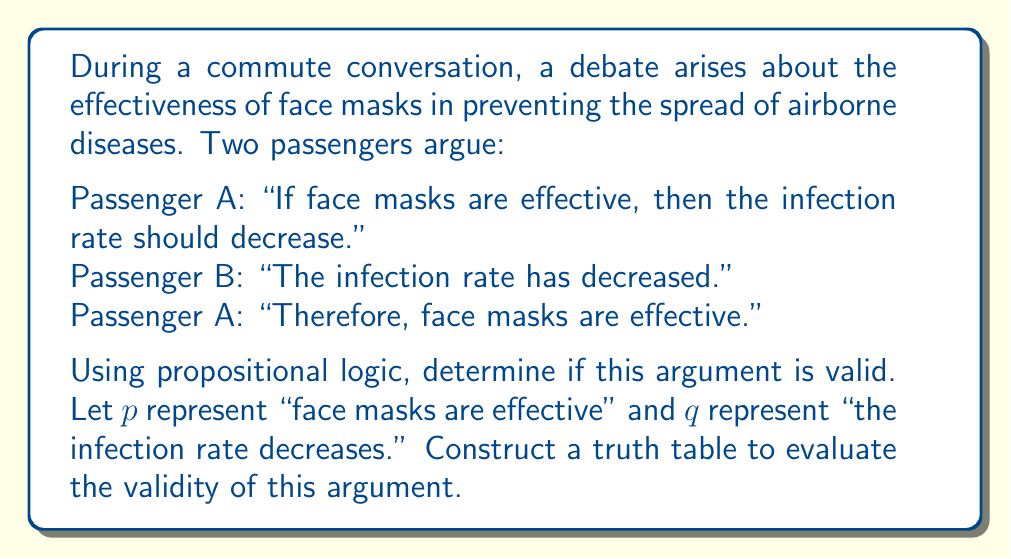Help me with this question. To evaluate the validity of this argument using propositional logic, we need to analyze the logical structure and construct a truth table. The argument can be broken down as follows:

1. Premise 1: $p \rightarrow q$ (If face masks are effective, then the infection rate should decrease)
2. Premise 2: $q$ (The infection rate has decreased)
3. Conclusion: $p$ (Therefore, face masks are effective)

This argument form is known as the fallacy of affirming the consequent. To prove its invalidity, we'll construct a truth table:

$$
\begin{array}{|c|c|c|c|c|}
\hline
p & q & p \rightarrow q & q & (p \rightarrow q) \land q \rightarrow p \\
\hline
T & T & T & T & T \\
T & F & F & F & T \\
F & T & T & T & F \\
F & F & T & F & T \\
\hline
\end{array}
$$

The last column represents the entire argument: $(p \rightarrow q) \land q \rightarrow p$

For an argument to be valid, the last column should be true for all possible combinations of p and q. However, we can see that in the third row, when p is false and q is true, the argument is false.

This demonstrates that it's possible for the premises to be true (face masks are not effective, but the infection rate has decreased) while the conclusion is false (face masks are not effective). Therefore, the argument is invalid.

The fallacy lies in assuming that if the consequent (q) is true, then the antecedent (p) must also be true. In reality, there could be other factors causing the decrease in infection rates, even if face masks are not effective.
Answer: The argument is invalid. The truth table shows that it's possible for the premises to be true while the conclusion is false, specifically when p is false and q is true. This demonstrates the fallacy of affirming the consequent. 